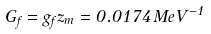<formula> <loc_0><loc_0><loc_500><loc_500>G _ { f } = g _ { f } z _ { m } = 0 . 0 1 7 4 \, M e V ^ { - 1 }</formula> 